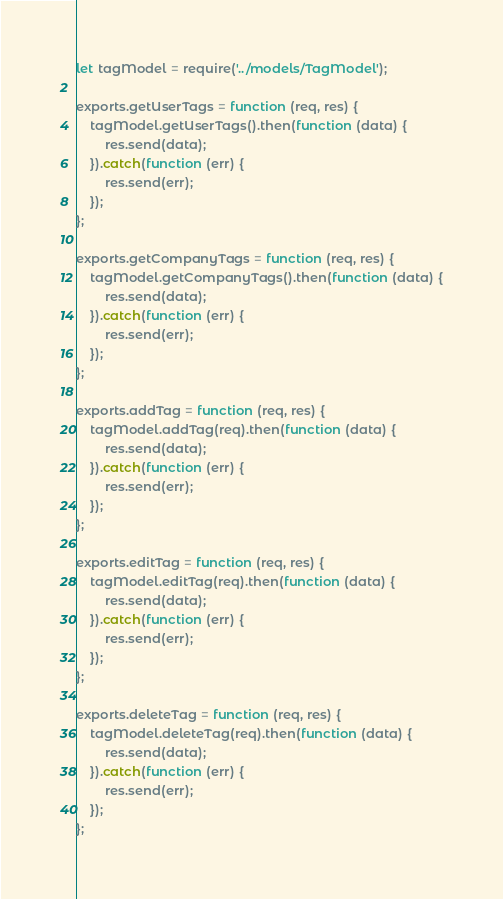Convert code to text. <code><loc_0><loc_0><loc_500><loc_500><_JavaScript_>let tagModel = require('../models/TagModel');

exports.getUserTags = function (req, res) {
    tagModel.getUserTags().then(function (data) {
        res.send(data);
    }).catch(function (err) {
        res.send(err);
    });
};

exports.getCompanyTags = function (req, res) {
    tagModel.getCompanyTags().then(function (data) {
        res.send(data);
    }).catch(function (err) {
        res.send(err);
    });
};

exports.addTag = function (req, res) {
    tagModel.addTag(req).then(function (data) {
        res.send(data);
    }).catch(function (err) {
        res.send(err);
    });
};

exports.editTag = function (req, res) {
    tagModel.editTag(req).then(function (data) {
        res.send(data);
    }).catch(function (err) {
        res.send(err);
    });
};

exports.deleteTag = function (req, res) {
    tagModel.deleteTag(req).then(function (data) {
        res.send(data);
    }).catch(function (err) {
        res.send(err);
    });
};</code> 